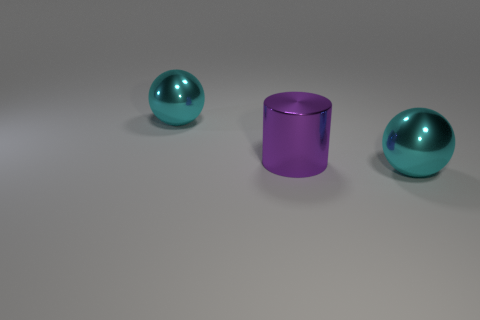There is a ball in front of the purple shiny cylinder; is it the same size as the object behind the purple cylinder?
Make the answer very short. Yes. What number of blocks are blue things or big shiny things?
Your response must be concise. 0. Is there a red sphere?
Your response must be concise. No. Is there any other thing that has the same shape as the purple metal thing?
Ensure brevity in your answer.  No. How many things are either large spheres in front of the purple cylinder or big red things?
Your answer should be compact. 1. What number of big cylinders are behind the large metallic sphere that is right of the metal sphere that is left of the big purple cylinder?
Provide a short and direct response. 1. There is a cyan object to the right of the large cyan thing left of the big cyan thing to the right of the purple metallic cylinder; what shape is it?
Your answer should be compact. Sphere. What is the shape of the cyan shiny thing that is to the right of the large cyan metallic sphere that is on the left side of the purple metallic thing?
Keep it short and to the point. Sphere. How many big cyan shiny spheres are behind the big purple metallic object?
Make the answer very short. 1. Are there any objects that have the same material as the large purple cylinder?
Make the answer very short. Yes. 